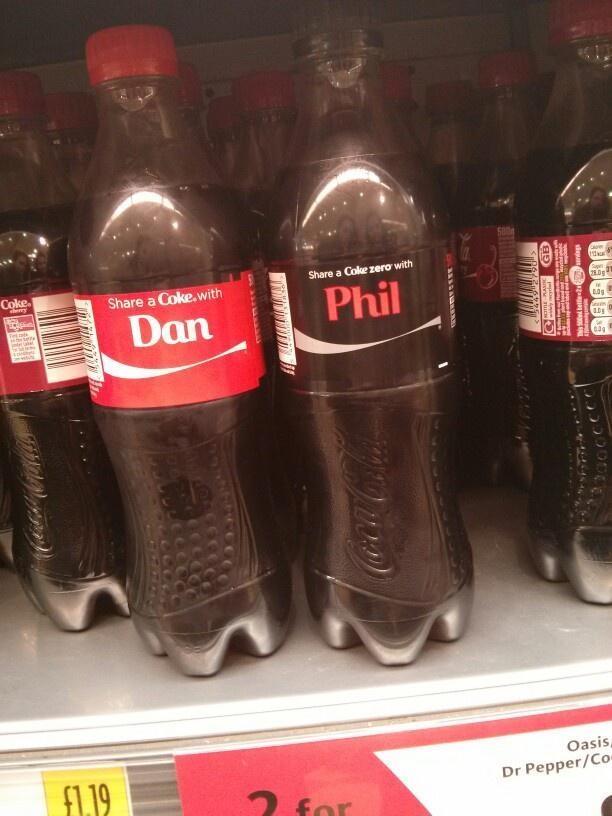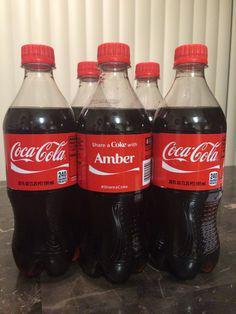The first image is the image on the left, the second image is the image on the right. Given the left and right images, does the statement "IN at least one image there is a display case of at least two shelves holding  sodas." hold true? Answer yes or no. No. 